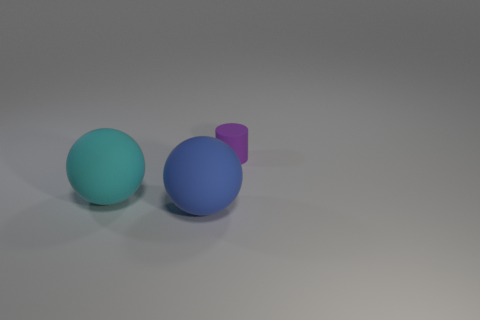Are there any other things that have the same size as the cylinder?
Keep it short and to the point. No. How many objects are made of the same material as the purple cylinder?
Your answer should be very brief. 2. How many objects are blue balls or objects behind the large blue thing?
Give a very brief answer. 3. What is the color of the large rubber object that is right of the rubber ball behind the big object that is right of the large cyan rubber ball?
Provide a succinct answer. Blue. How big is the purple matte cylinder that is right of the blue rubber object?
Ensure brevity in your answer.  Small. What number of tiny objects are either purple cylinders or purple spheres?
Provide a short and direct response. 1. What color is the rubber object that is behind the large blue object and in front of the tiny purple thing?
Provide a succinct answer. Cyan. Are there any other big rubber objects of the same shape as the cyan thing?
Provide a short and direct response. Yes. What material is the large blue object?
Ensure brevity in your answer.  Rubber. Are there any spheres on the right side of the cyan matte sphere?
Offer a very short reply. Yes. 